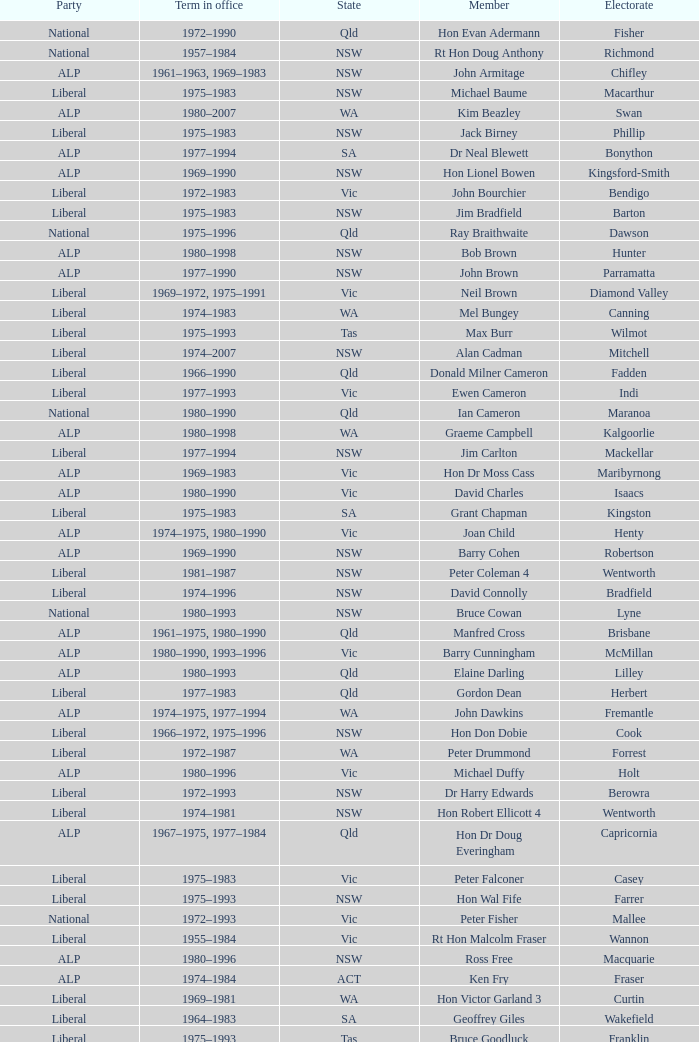When was Hon Les Johnson in office? 1955–1966, 1969–1984. Parse the table in full. {'header': ['Party', 'Term in office', 'State', 'Member', 'Electorate'], 'rows': [['National', '1972–1990', 'Qld', 'Hon Evan Adermann', 'Fisher'], ['National', '1957–1984', 'NSW', 'Rt Hon Doug Anthony', 'Richmond'], ['ALP', '1961–1963, 1969–1983', 'NSW', 'John Armitage', 'Chifley'], ['Liberal', '1975–1983', 'NSW', 'Michael Baume', 'Macarthur'], ['ALP', '1980–2007', 'WA', 'Kim Beazley', 'Swan'], ['Liberal', '1975–1983', 'NSW', 'Jack Birney', 'Phillip'], ['ALP', '1977–1994', 'SA', 'Dr Neal Blewett', 'Bonython'], ['ALP', '1969–1990', 'NSW', 'Hon Lionel Bowen', 'Kingsford-Smith'], ['Liberal', '1972–1983', 'Vic', 'John Bourchier', 'Bendigo'], ['Liberal', '1975–1983', 'NSW', 'Jim Bradfield', 'Barton'], ['National', '1975–1996', 'Qld', 'Ray Braithwaite', 'Dawson'], ['ALP', '1980–1998', 'NSW', 'Bob Brown', 'Hunter'], ['ALP', '1977–1990', 'NSW', 'John Brown', 'Parramatta'], ['Liberal', '1969–1972, 1975–1991', 'Vic', 'Neil Brown', 'Diamond Valley'], ['Liberal', '1974–1983', 'WA', 'Mel Bungey', 'Canning'], ['Liberal', '1975–1993', 'Tas', 'Max Burr', 'Wilmot'], ['Liberal', '1974–2007', 'NSW', 'Alan Cadman', 'Mitchell'], ['Liberal', '1966–1990', 'Qld', 'Donald Milner Cameron', 'Fadden'], ['Liberal', '1977–1993', 'Vic', 'Ewen Cameron', 'Indi'], ['National', '1980–1990', 'Qld', 'Ian Cameron', 'Maranoa'], ['ALP', '1980–1998', 'WA', 'Graeme Campbell', 'Kalgoorlie'], ['Liberal', '1977–1994', 'NSW', 'Jim Carlton', 'Mackellar'], ['ALP', '1969–1983', 'Vic', 'Hon Dr Moss Cass', 'Maribyrnong'], ['ALP', '1980–1990', 'Vic', 'David Charles', 'Isaacs'], ['Liberal', '1975–1983', 'SA', 'Grant Chapman', 'Kingston'], ['ALP', '1974–1975, 1980–1990', 'Vic', 'Joan Child', 'Henty'], ['ALP', '1969–1990', 'NSW', 'Barry Cohen', 'Robertson'], ['Liberal', '1981–1987', 'NSW', 'Peter Coleman 4', 'Wentworth'], ['Liberal', '1974–1996', 'NSW', 'David Connolly', 'Bradfield'], ['National', '1980–1993', 'NSW', 'Bruce Cowan', 'Lyne'], ['ALP', '1961–1975, 1980–1990', 'Qld', 'Manfred Cross', 'Brisbane'], ['ALP', '1980–1990, 1993–1996', 'Vic', 'Barry Cunningham', 'McMillan'], ['ALP', '1980–1993', 'Qld', 'Elaine Darling', 'Lilley'], ['Liberal', '1977–1983', 'Qld', 'Gordon Dean', 'Herbert'], ['ALP', '1974–1975, 1977–1994', 'WA', 'John Dawkins', 'Fremantle'], ['Liberal', '1966–1972, 1975–1996', 'NSW', 'Hon Don Dobie', 'Cook'], ['Liberal', '1972–1987', 'WA', 'Peter Drummond', 'Forrest'], ['ALP', '1980–1996', 'Vic', 'Michael Duffy', 'Holt'], ['Liberal', '1972–1993', 'NSW', 'Dr Harry Edwards', 'Berowra'], ['Liberal', '1974–1981', 'NSW', 'Hon Robert Ellicott 4', 'Wentworth'], ['ALP', '1967–1975, 1977–1984', 'Qld', 'Hon Dr Doug Everingham', 'Capricornia'], ['Liberal', '1975–1983', 'Vic', 'Peter Falconer', 'Casey'], ['Liberal', '1975–1993', 'NSW', 'Hon Wal Fife', 'Farrer'], ['National', '1972–1993', 'Vic', 'Peter Fisher', 'Mallee'], ['Liberal', '1955–1984', 'Vic', 'Rt Hon Malcolm Fraser', 'Wannon'], ['ALP', '1980–1996', 'NSW', 'Ross Free', 'Macquarie'], ['ALP', '1974–1984', 'ACT', 'Ken Fry', 'Fraser'], ['Liberal', '1969–1981', 'WA', 'Hon Victor Garland 3', 'Curtin'], ['Liberal', '1964–1983', 'SA', 'Geoffrey Giles', 'Wakefield'], ['Liberal', '1975–1993', 'Tas', 'Bruce Goodluck', 'Franklin'], ['Liberal', '1975–1984', 'Tas', 'Hon Ray Groom', 'Braddon'], ['Liberal', '1981–1996', 'SA', 'Steele Hall 2', 'Boothby'], ['Liberal', '1980–1983', 'Vic', 'Graham Harris', 'Chisholm'], ['ALP', '1980–1992', 'Vic', 'Bob Hawke', 'Wills'], ['ALP', '1961–1988', 'Qld', 'Hon Bill Hayden', 'Oxley'], ['National', '1980–1998', 'NSW', 'Noel Hicks', 'Riverina'], ['Liberal', '1974–1983, 1984–1987', 'Qld', 'John Hodges', 'Petrie'], ['Liberal', '1975–1987', 'Tas', 'Michael Hodgman', 'Denison'], ['ALP', '1977–1998', 'Vic', 'Clyde Holding', 'Melbourne Ports'], ['Liberal', '1974–2007', 'NSW', 'Hon John Howard', 'Bennelong'], ['ALP', '1977–1996', 'Vic', 'Brian Howe', 'Batman'], ['ALP', '1977–1996', 'Qld', 'Ben Humphreys', 'Griffith'], ['National', '1969–1989', 'NSW', 'Hon Ralph Hunt', 'Gwydir'], ['ALP', '1969–1988', 'SA', 'Chris Hurford', 'Adelaide'], ['Liberal', '1974–1983', 'WA', 'John Hyde', 'Moore'], ['ALP', '1972–1983', 'Vic', 'Ted Innes', 'Melbourne'], ['ALP', '1969–1987', 'SA', 'Ralph Jacobi', 'Hawker'], ['Liberal', '1966–1983', 'Vic', 'Alan Jarman', 'Deakin'], ['ALP', '1969–1985', 'Vic', 'Dr Harry Jenkins', 'Scullin'], ['ALP', '1955–1966, 1969–1984', 'NSW', 'Hon Les Johnson', 'Hughes'], ['ALP', '1977–1998', 'Vic', 'Barry Jones', 'Lalor'], ['ALP', '1958–1983', 'NSW', 'Hon Charles Jones', 'Newcastle'], ['Liberal', '1975–1983, 1984–2007', 'Qld', 'David Jull', 'Bowman'], ['National', '1966–1990', 'Qld', 'Hon Bob Katter', 'Kennedy'], ['ALP', '1969–1996', 'NSW', 'Hon Paul Keating', 'Blaxland'], ['ALP', '1980–1995', 'ACT', 'Ros Kelly', 'Canberra'], ['ALP', '1980–1990', 'Vic', 'Lewis Kent', 'Hotham'], ['ALP', '1972–1975, 1978–1994', 'NSW', 'John Kerin', 'Werriwa'], ['Liberal', '1955–1983', 'Qld', 'Hon Jim Killen', 'Moreton'], ['ALP', '1969–1990', 'NSW', 'Dr Dick Klugman', 'Prospect'], ['National', '1971–1996', 'Vic', 'Bruce Lloyd', 'Murray'], ['National', '1974–1984', 'NSW', 'Stephen Lusher', 'Hume'], ['Liberal', '1966–1982', 'Vic', 'Rt Hon Phillip Lynch 6', 'Flinders'], ['Liberal', '1969–1994', 'NSW', 'Hon Michael MacKellar', 'Warringah'], ['National', '1975–1983', 'NSW', 'Sandy Mackenzie', 'Calare'], ['Liberal', '1974–1990', 'Vic', 'Hon Ian Macphee', 'Balaclava'], ['ALP', '1982–1987', 'NSW', 'Michael Maher 5', 'Lowe'], ['Liberal', '1975–1983', 'WA', 'Ross McLean', 'Perth'], ['Liberal', '1966–1981', 'SA', 'Hon John McLeay 2', 'Boothby'], ['ALP', '1979–2004', 'NSW', 'Leo McLeay', 'Grayndler'], ['ALP', '1975–1983', 'NSW', 'Leslie McMahon', 'Sydney'], ['Liberal', '1949–1981', 'NSW', 'Rt Hon Sir William McMahon 5', 'Lowe'], ['National', '1972–1988', 'Qld', 'Tom McVeigh', 'Darling Downs'], ['ALP', '1980–1990', 'Vic', 'John Mildren', 'Ballarat'], ['National', '1974–1990', 'Qld', 'Clarrie Millar', 'Wide Bay'], ['ALP', '1980–1990', 'Vic', 'Peter Milton', 'La Trobe'], ['Liberal', '1975–2001', 'Qld', 'John Moore', 'Ryan'], ['ALP', '1972–1998', 'NSW', 'Peter Morris', 'Shortland'], ['ALP', '1969–1975, 1980–1984', 'NSW', 'Hon Bill Morrison', 'St George'], ['ALP', '1980–1990', 'NSW', 'John Mountford', 'Banks'], ['Liberal', '1975–1984', 'Tas', 'Hon Kevin Newman', 'Bass'], ['National', '1961–1983', 'Vic', 'Hon Peter Nixon', 'Gippsland'], ['National', '1969–1984', 'NSW', "Frank O'Keefe", 'Paterson'], ['Liberal', '1966–1994', 'Vic', 'Hon Andrew Peacock', 'Kooyong'], ['Liberal', '1975–1990', 'SA', 'James Porter', 'Barker'], ['Liberal', '1982–1983, 1984–2001', 'Vic', 'Peter Reith 6', 'Flinders'], ['Liberal', '1972–1990', 'Qld', 'Hon Eric Robinson 1', 'McPherson'], ['National', '1963–1981', 'NSW', 'Hon Ian Robinson', 'Cowper'], ['Liberal', '1981–1998', 'WA', 'Allan Rocher 3', 'Curtin'], ['Liberal', '1973–present', 'NSW', 'Philip Ruddock', 'Dundas'], ['Liberal', '1975–1983', 'NSW', 'Murray Sainsbury', 'Eden-Monaro'], ['ALP', '1967–1993', 'Vic', 'Hon Gordon Scholes', 'Corio'], ['ALP', '1980–1993', 'SA', 'John Scott', 'Hindmarsh'], ['Liberal', '1977–1983, 1984–1993', 'WA', 'Peter Shack', 'Tangney'], ['Liberal', '1975–1990', 'Vic', 'Roger Shipton', 'Higgins'], ['National', '1963–1998', 'NSW', 'Rt Hon Ian Sinclair', 'New England'], ['Liberal', '1955–1983', 'Vic', 'Rt Hon Sir Billy Snedden', 'Bruce'], ['Liberal', '1980–1990', 'NSW', 'John Spender', 'North Sydney'], ['Liberal', '1966–1984', 'Vic', 'Hon Tony Street', 'Corangamite'], ['CLP', '1980–1983', 'NT', 'Grant Tambling', 'Northern Territory'], ['ALP', '1980–2001', 'Vic', 'Dr Andrew Theophanous', 'Burke'], ['National', '1975–1983', 'Qld', 'Hon David Thomson', 'Leichhardt'], ['Liberal', '1980–2010', 'WA', 'Wilson Tuckey', "O'Connor"], ['ALP', '1958–1990', 'NSW', 'Hon Tom Uren', 'Reid'], ['Liberal', '1972–1983', 'WA', 'Hon Ian Viner', 'Stirling'], ['ALP', '1969–1983', 'SA', 'Laurie Wallis', 'Grey'], ['ALP', '1977–1993', 'NSW', 'Stewart West', 'Cunningham'], ['Liberal', '1981–1990', 'Qld', 'Peter White 1', 'McPherson'], ['ALP', '1972–1998', 'Vic', 'Ralph Willis', 'Gellibrand'], ['Liberal', '1966–1969, 1972–1993', 'SA', 'Ian Wilson', 'Sturt'], ['ALP', '1974–1988', 'SA', 'Mick Young', 'Port Adelaide']]} 